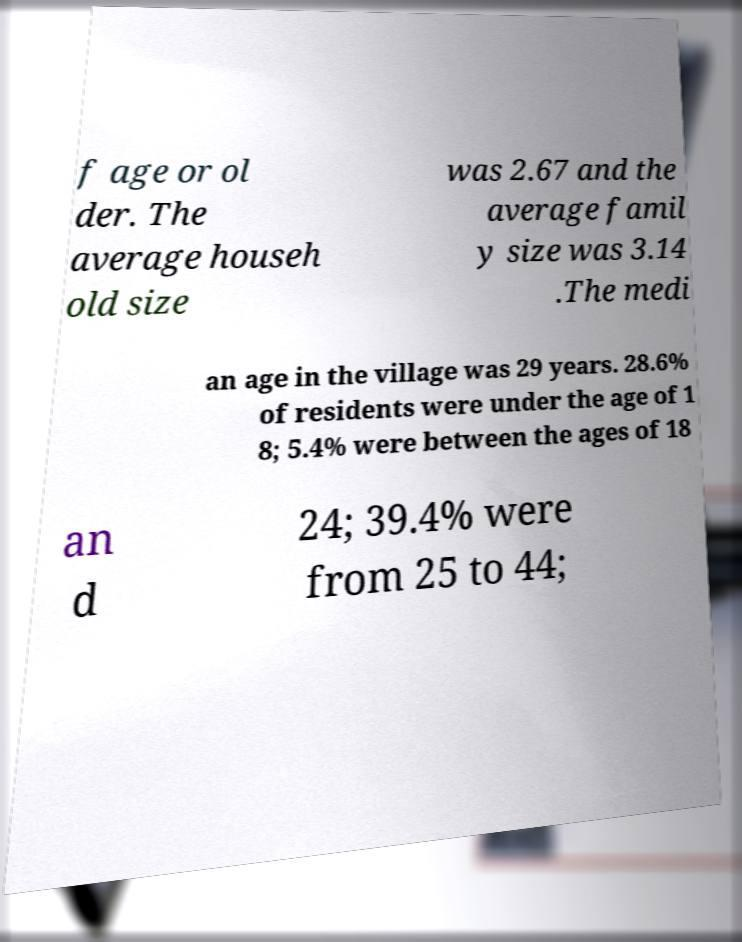Can you read and provide the text displayed in the image?This photo seems to have some interesting text. Can you extract and type it out for me? f age or ol der. The average househ old size was 2.67 and the average famil y size was 3.14 .The medi an age in the village was 29 years. 28.6% of residents were under the age of 1 8; 5.4% were between the ages of 18 an d 24; 39.4% were from 25 to 44; 